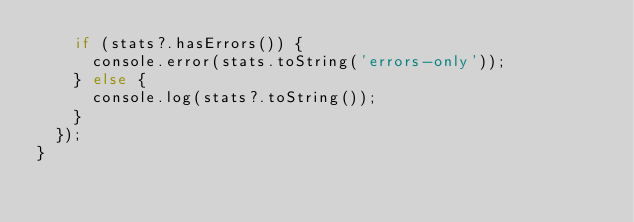<code> <loc_0><loc_0><loc_500><loc_500><_TypeScript_>    if (stats?.hasErrors()) {
      console.error(stats.toString('errors-only'));
    } else {
      console.log(stats?.toString());
    }
  });
}
</code> 